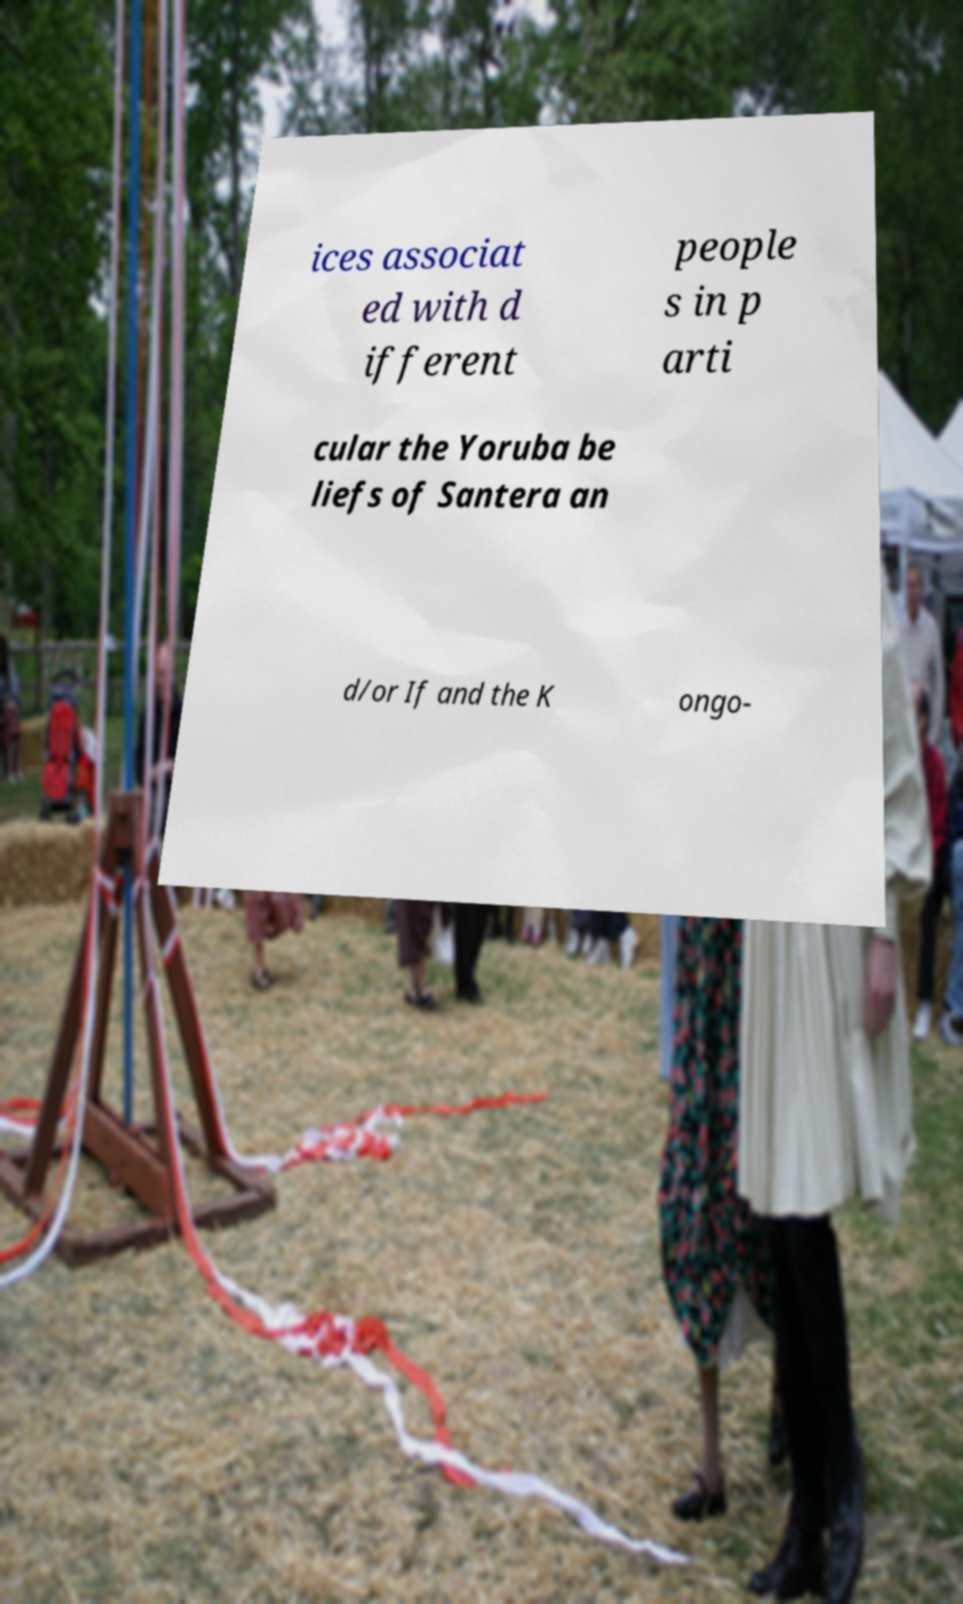What messages or text are displayed in this image? I need them in a readable, typed format. ices associat ed with d ifferent people s in p arti cular the Yoruba be liefs of Santera an d/or If and the K ongo- 